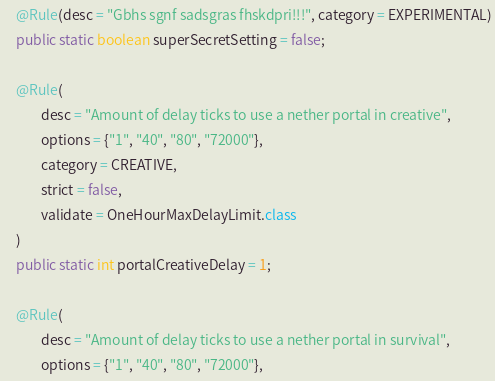<code> <loc_0><loc_0><loc_500><loc_500><_Java_>


    @Rule(desc = "Gbhs sgnf sadsgras fhskdpri!!!", category = EXPERIMENTAL)
    public static boolean superSecretSetting = false;

    @Rule(
            desc = "Amount of delay ticks to use a nether portal in creative",
            options = {"1", "40", "80", "72000"},
            category = CREATIVE,
            strict = false,
            validate = OneHourMaxDelayLimit.class
    )
    public static int portalCreativeDelay = 1;

    @Rule(
            desc = "Amount of delay ticks to use a nether portal in survival",
            options = {"1", "40", "80", "72000"},</code> 